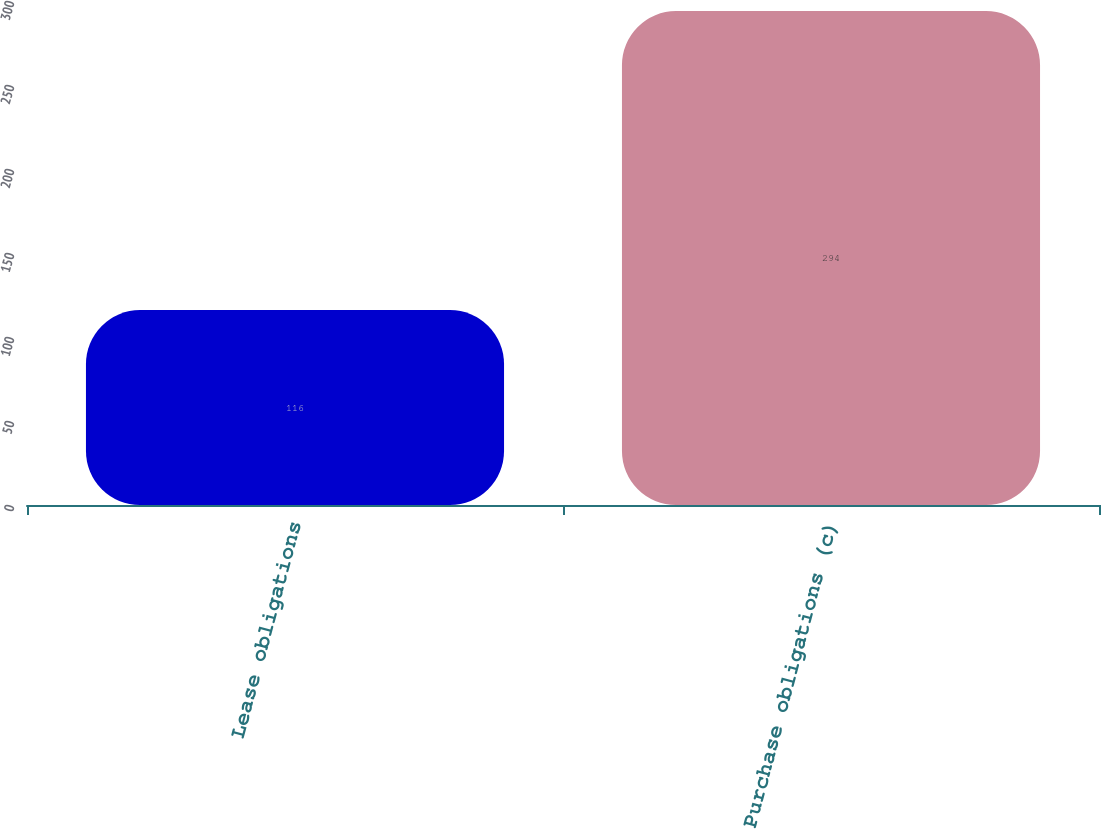Convert chart to OTSL. <chart><loc_0><loc_0><loc_500><loc_500><bar_chart><fcel>Lease obligations<fcel>Purchase obligations (c)<nl><fcel>116<fcel>294<nl></chart> 